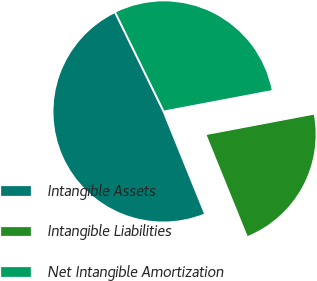Convert chart to OTSL. <chart><loc_0><loc_0><loc_500><loc_500><pie_chart><fcel>Intangible Assets<fcel>Intangible Liabilities<fcel>Net Intangible Amortization<nl><fcel>48.88%<fcel>21.85%<fcel>29.27%<nl></chart> 